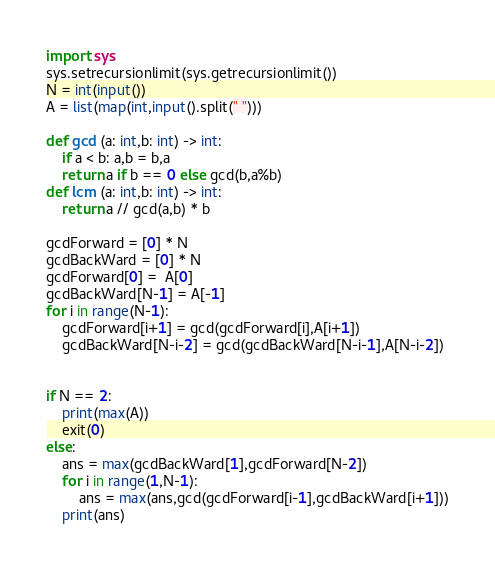<code> <loc_0><loc_0><loc_500><loc_500><_Python_>import sys
sys.setrecursionlimit(sys.getrecursionlimit())
N = int(input())
A = list(map(int,input().split(" ")))

def gcd (a: int,b: int) -> int:
    if a < b: a,b = b,a
    return a if b == 0 else gcd(b,a%b)
def lcm (a: int,b: int) -> int:
    return a // gcd(a,b) * b

gcdForward = [0] * N
gcdBackWard = [0] * N
gcdForward[0] =  A[0]
gcdBackWard[N-1] = A[-1]
for i in range(N-1):
    gcdForward[i+1] = gcd(gcdForward[i],A[i+1])
    gcdBackWard[N-i-2] = gcd(gcdBackWard[N-i-1],A[N-i-2])


if N == 2:
    print(max(A))
    exit(0)
else:
    ans = max(gcdBackWard[1],gcdForward[N-2])
    for i in range(1,N-1):
        ans = max(ans,gcd(gcdForward[i-1],gcdBackWard[i+1]))
    print(ans)</code> 